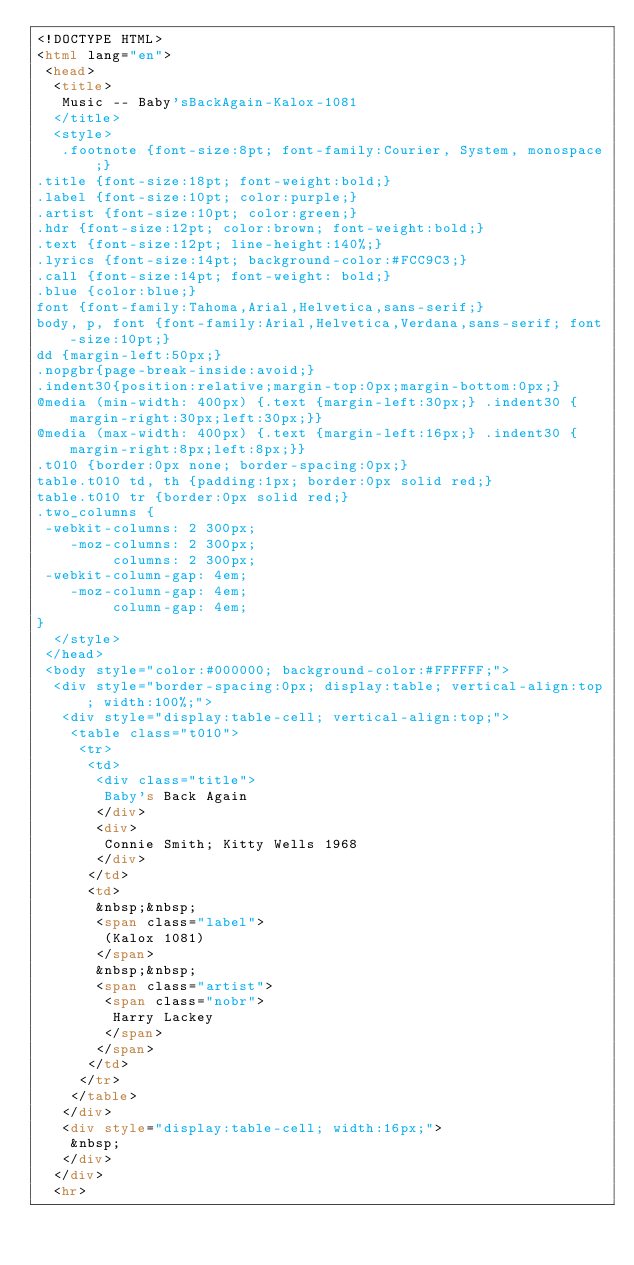<code> <loc_0><loc_0><loc_500><loc_500><_HTML_><!DOCTYPE HTML>
<html lang="en">
 <head>
  <title>
   Music -- Baby'sBackAgain-Kalox-1081
  </title>
  <style>
   .footnote {font-size:8pt; font-family:Courier, System, monospace;}
.title {font-size:18pt; font-weight:bold;}
.label {font-size:10pt; color:purple;}
.artist {font-size:10pt; color:green;}
.hdr {font-size:12pt; color:brown; font-weight:bold;}
.text {font-size:12pt; line-height:140%;}
.lyrics {font-size:14pt; background-color:#FCC9C3;}
.call {font-size:14pt; font-weight: bold;}
.blue {color:blue;}
font {font-family:Tahoma,Arial,Helvetica,sans-serif;}
body, p, font {font-family:Arial,Helvetica,Verdana,sans-serif; font-size:10pt;}
dd {margin-left:50px;}
.nopgbr{page-break-inside:avoid;}
.indent30{position:relative;margin-top:0px;margin-bottom:0px;}
@media (min-width: 400px) {.text {margin-left:30px;} .indent30 {margin-right:30px;left:30px;}}
@media (max-width: 400px) {.text {margin-left:16px;} .indent30 {margin-right:8px;left:8px;}}
.t010 {border:0px none; border-spacing:0px;}
table.t010 td, th {padding:1px; border:0px solid red;}
table.t010 tr {border:0px solid red;}
.two_columns {
 -webkit-columns: 2 300px;
    -moz-columns: 2 300px;
         columns: 2 300px;
 -webkit-column-gap: 4em;
    -moz-column-gap: 4em;
         column-gap: 4em;
}
  </style>
 </head>
 <body style="color:#000000; background-color:#FFFFFF;">
  <div style="border-spacing:0px; display:table; vertical-align:top; width:100%;">
   <div style="display:table-cell; vertical-align:top;">
    <table class="t010">
     <tr>
      <td>
       <div class="title">
        Baby's Back Again
       </div>
       <div>
        Connie Smith; Kitty Wells 1968
       </div>
      </td>
      <td>
       &nbsp;&nbsp;
       <span class="label">
        (Kalox 1081)
       </span>
       &nbsp;&nbsp;
       <span class="artist">
        <span class="nobr">
         Harry Lackey
        </span>
       </span>
      </td>
     </tr>
    </table>
   </div>
   <div style="display:table-cell; width:16px;">
    &nbsp;
   </div>
  </div>
  <hr></code> 